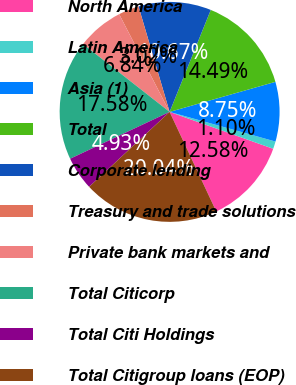Convert chart to OTSL. <chart><loc_0><loc_0><loc_500><loc_500><pie_chart><fcel>North America<fcel>Latin America<fcel>Asia (1)<fcel>Total<fcel>Corporate lending<fcel>Treasury and trade solutions<fcel>Private bank markets and<fcel>Total Citicorp<fcel>Total Citi Holdings<fcel>Total Citigroup loans (EOP)<nl><fcel>12.58%<fcel>1.1%<fcel>8.75%<fcel>14.49%<fcel>10.67%<fcel>3.02%<fcel>6.84%<fcel>17.58%<fcel>4.93%<fcel>20.04%<nl></chart> 